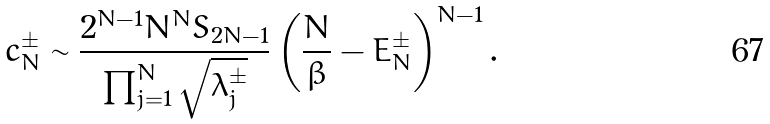Convert formula to latex. <formula><loc_0><loc_0><loc_500><loc_500>c _ { N } ^ { \pm } \sim \frac { 2 ^ { N - 1 } N ^ { N } S _ { 2 N - 1 } } { \prod _ { j = 1 } ^ { N } \sqrt { \lambda ^ { \pm } _ { j } } } \left ( \frac { N } { \beta } - E _ { N } ^ { \pm } \right ) ^ { N - 1 } .</formula> 